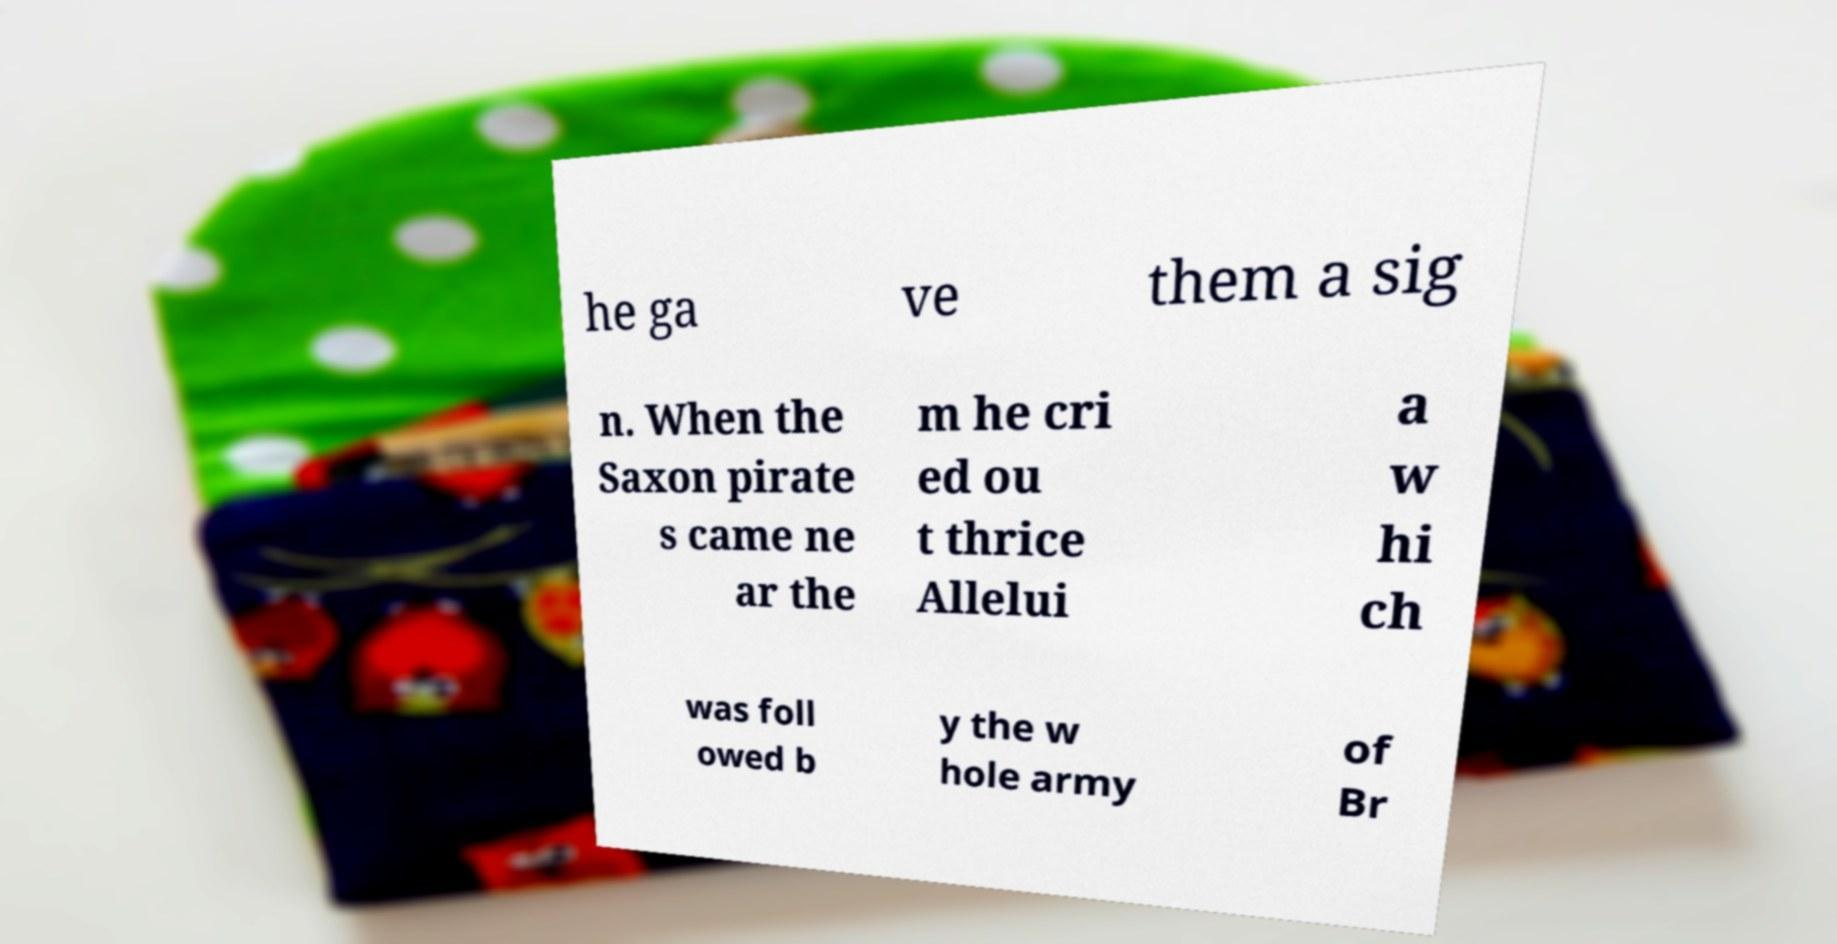For documentation purposes, I need the text within this image transcribed. Could you provide that? he ga ve them a sig n. When the Saxon pirate s came ne ar the m he cri ed ou t thrice Allelui a w hi ch was foll owed b y the w hole army of Br 